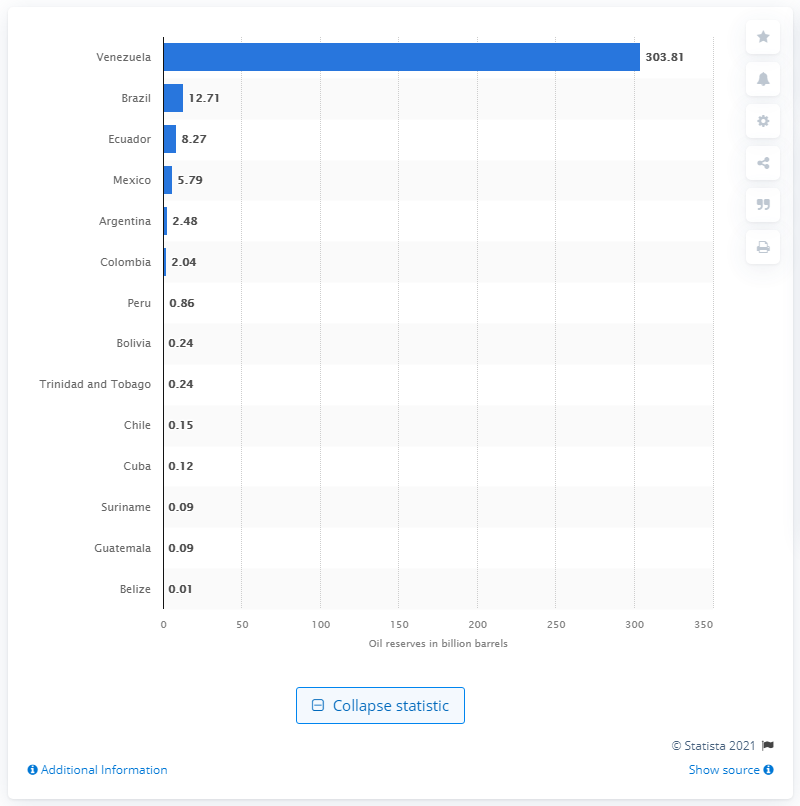Outline some significant characteristics in this image. Brazil had the largest crude oil reserves in the region. According to official data, as of 2021, Venezuela's crude oil reserves were approximately 303.81 billion barrels. 